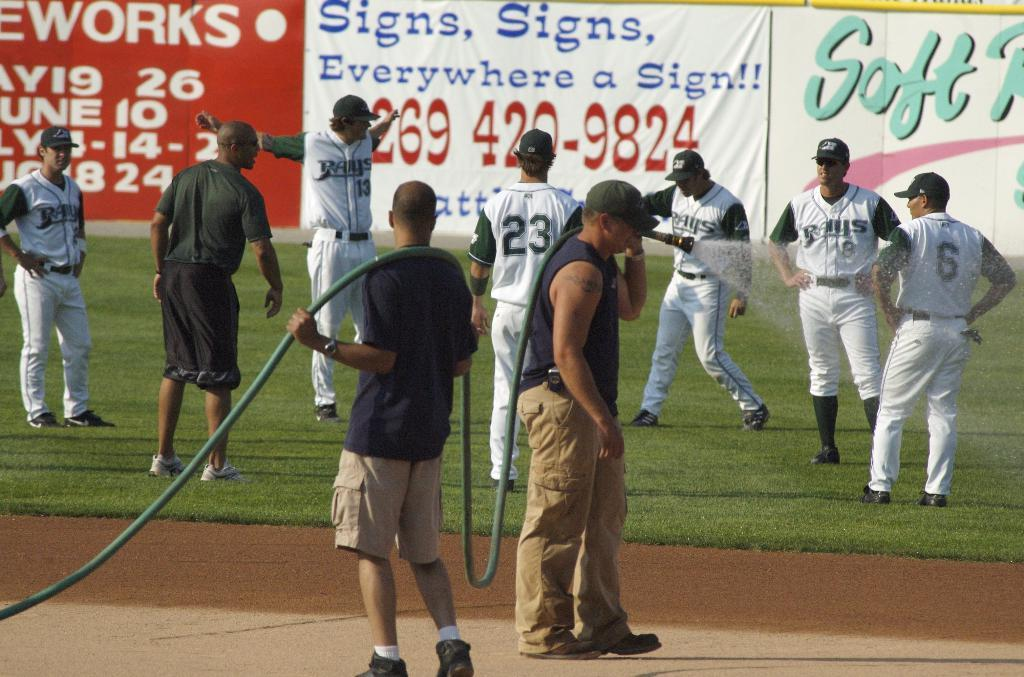<image>
Offer a succinct explanation of the picture presented. Numerous baseball players of the Rays on the outfield grass of a baseball field 